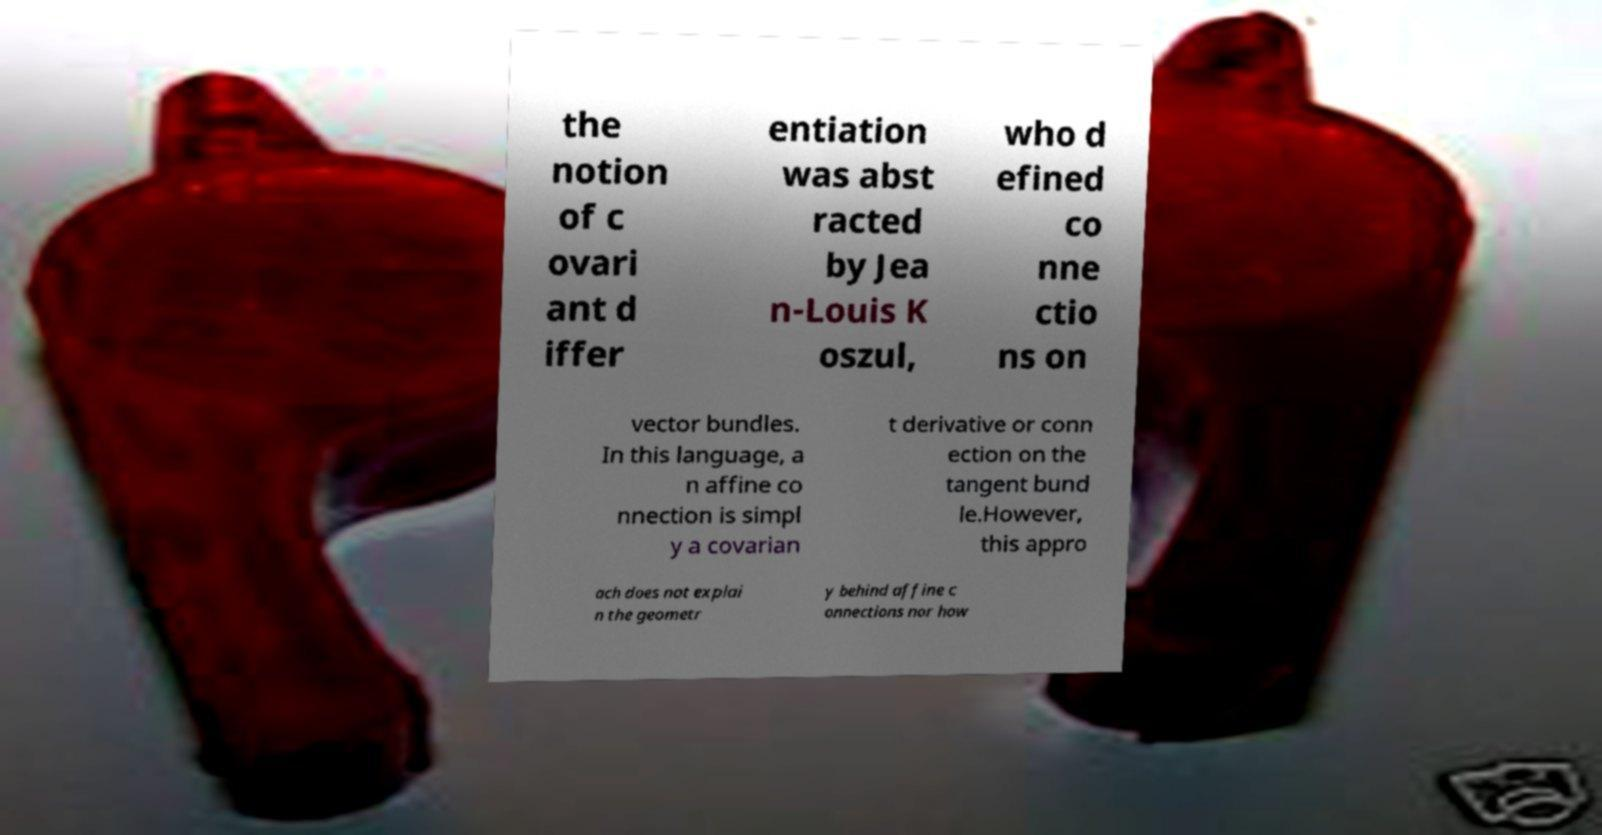I need the written content from this picture converted into text. Can you do that? the notion of c ovari ant d iffer entiation was abst racted by Jea n-Louis K oszul, who d efined co nne ctio ns on vector bundles. In this language, a n affine co nnection is simpl y a covarian t derivative or conn ection on the tangent bund le.However, this appro ach does not explai n the geometr y behind affine c onnections nor how 